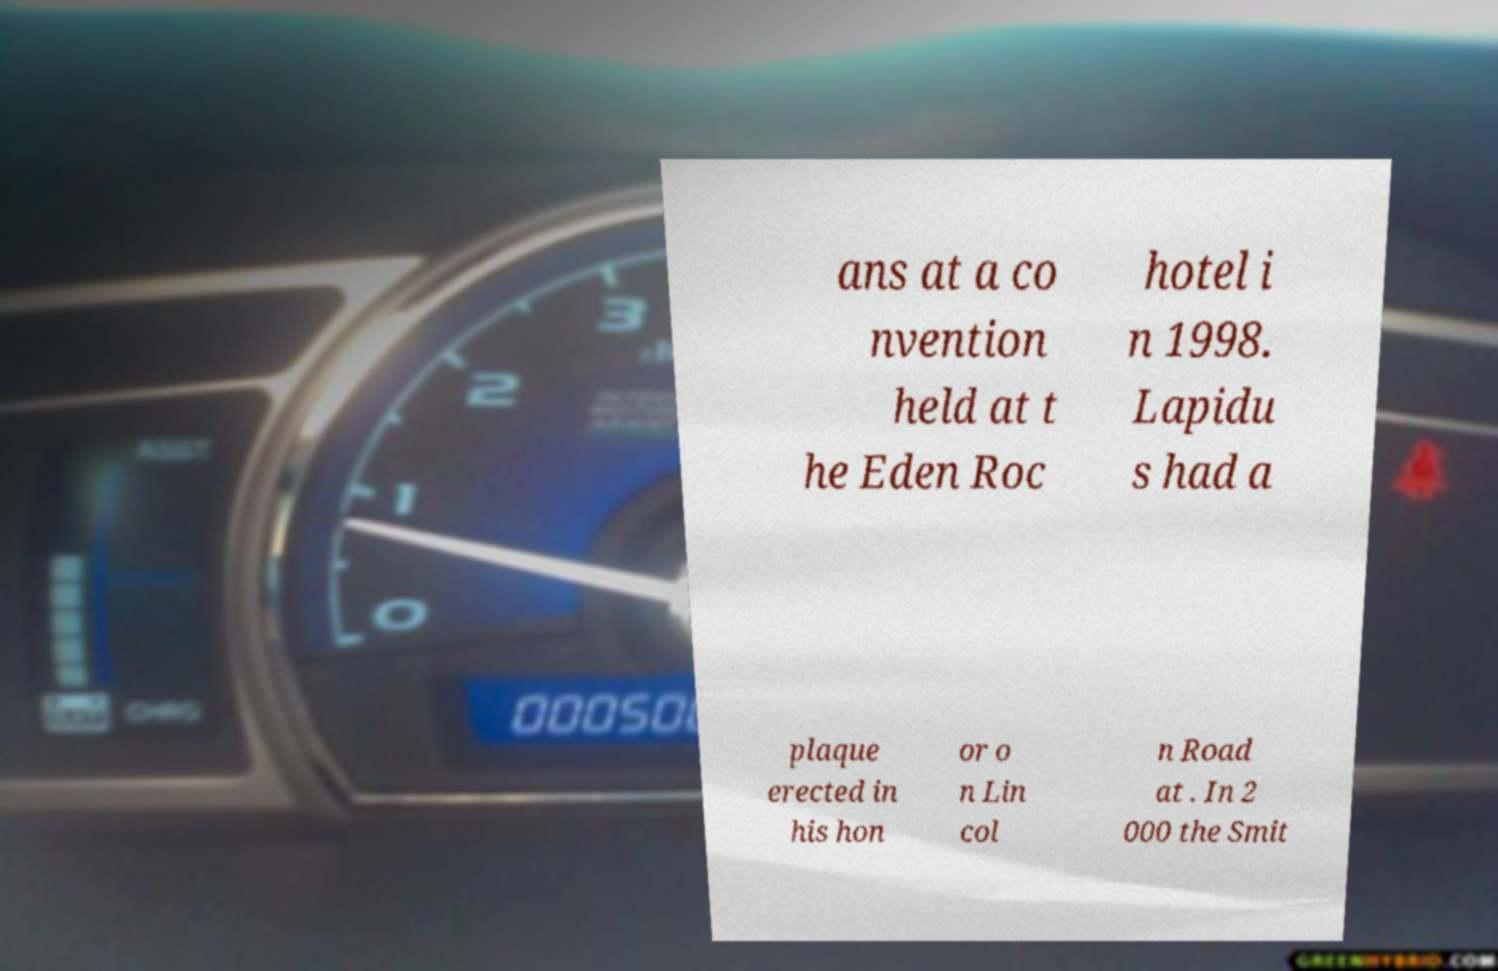For documentation purposes, I need the text within this image transcribed. Could you provide that? ans at a co nvention held at t he Eden Roc hotel i n 1998. Lapidu s had a plaque erected in his hon or o n Lin col n Road at . In 2 000 the Smit 